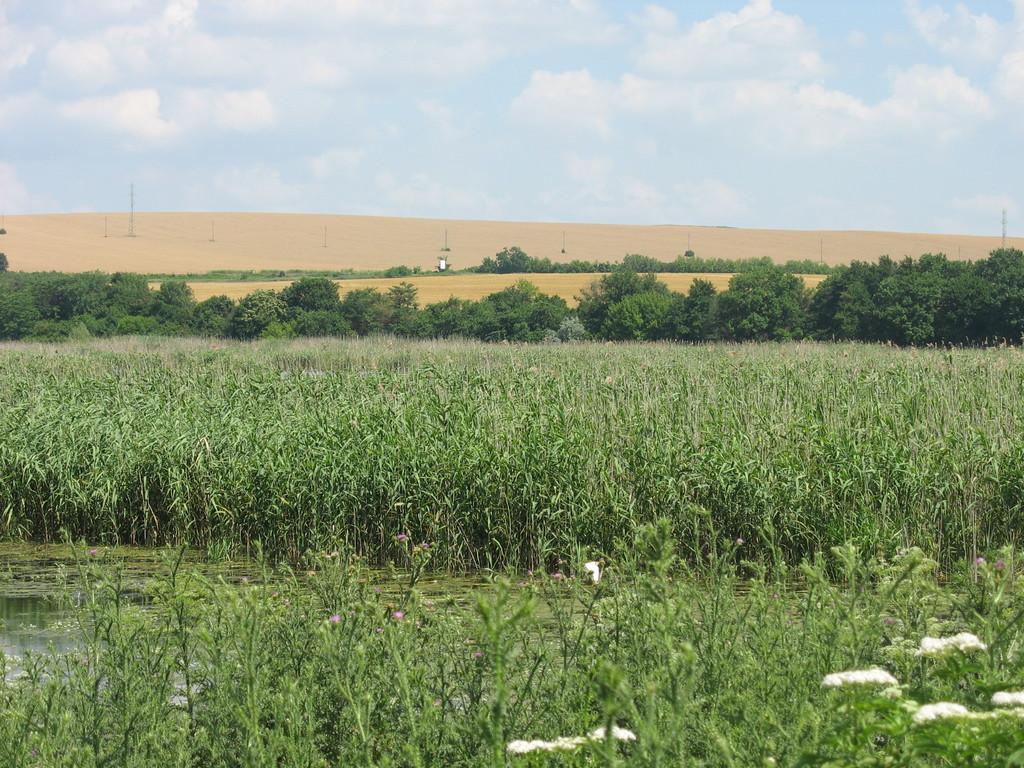Describe this image in one or two sentences. There are lot of plants over here and also plants where their is a white color on the top and here is small amount of water and here is also a sky which is blue in color and also cloudy this is the sand with towers placed on the sand there are also trees which are dark green in color. 